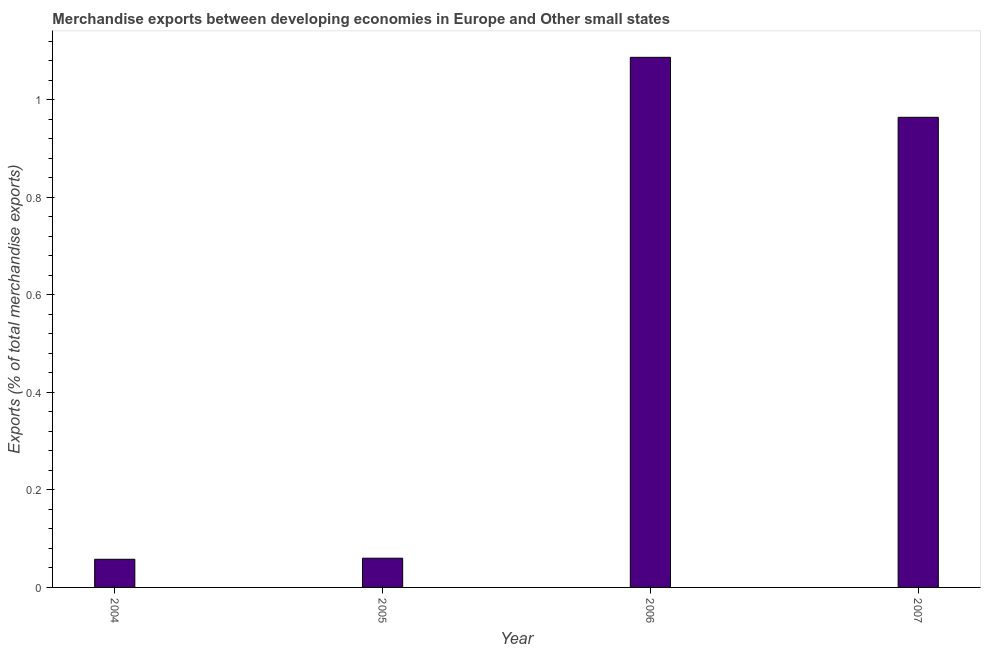Does the graph contain any zero values?
Make the answer very short. No. What is the title of the graph?
Offer a terse response. Merchandise exports between developing economies in Europe and Other small states. What is the label or title of the X-axis?
Your answer should be compact. Year. What is the label or title of the Y-axis?
Provide a succinct answer. Exports (% of total merchandise exports). What is the merchandise exports in 2007?
Make the answer very short. 0.96. Across all years, what is the maximum merchandise exports?
Your answer should be very brief. 1.09. Across all years, what is the minimum merchandise exports?
Provide a short and direct response. 0.06. In which year was the merchandise exports maximum?
Keep it short and to the point. 2006. What is the sum of the merchandise exports?
Offer a very short reply. 2.17. What is the difference between the merchandise exports in 2006 and 2007?
Provide a short and direct response. 0.12. What is the average merchandise exports per year?
Your answer should be very brief. 0.54. What is the median merchandise exports?
Your answer should be compact. 0.51. In how many years, is the merchandise exports greater than 1.08 %?
Offer a very short reply. 1. What is the ratio of the merchandise exports in 2004 to that in 2006?
Keep it short and to the point. 0.05. Is the difference between the merchandise exports in 2006 and 2007 greater than the difference between any two years?
Keep it short and to the point. No. What is the difference between the highest and the second highest merchandise exports?
Ensure brevity in your answer.  0.12. Is the sum of the merchandise exports in 2004 and 2006 greater than the maximum merchandise exports across all years?
Your answer should be very brief. Yes. What is the difference between the highest and the lowest merchandise exports?
Ensure brevity in your answer.  1.03. Are all the bars in the graph horizontal?
Your answer should be very brief. No. How many years are there in the graph?
Make the answer very short. 4. What is the Exports (% of total merchandise exports) in 2004?
Your response must be concise. 0.06. What is the Exports (% of total merchandise exports) of 2005?
Offer a terse response. 0.06. What is the Exports (% of total merchandise exports) in 2006?
Your answer should be very brief. 1.09. What is the Exports (% of total merchandise exports) in 2007?
Keep it short and to the point. 0.96. What is the difference between the Exports (% of total merchandise exports) in 2004 and 2005?
Your answer should be compact. -0. What is the difference between the Exports (% of total merchandise exports) in 2004 and 2006?
Your answer should be compact. -1.03. What is the difference between the Exports (% of total merchandise exports) in 2004 and 2007?
Provide a short and direct response. -0.91. What is the difference between the Exports (% of total merchandise exports) in 2005 and 2006?
Your answer should be compact. -1.03. What is the difference between the Exports (% of total merchandise exports) in 2005 and 2007?
Your answer should be very brief. -0.9. What is the difference between the Exports (% of total merchandise exports) in 2006 and 2007?
Offer a terse response. 0.12. What is the ratio of the Exports (% of total merchandise exports) in 2004 to that in 2005?
Your answer should be very brief. 0.96. What is the ratio of the Exports (% of total merchandise exports) in 2004 to that in 2006?
Offer a terse response. 0.05. What is the ratio of the Exports (% of total merchandise exports) in 2005 to that in 2006?
Ensure brevity in your answer.  0.06. What is the ratio of the Exports (% of total merchandise exports) in 2005 to that in 2007?
Offer a terse response. 0.06. What is the ratio of the Exports (% of total merchandise exports) in 2006 to that in 2007?
Keep it short and to the point. 1.13. 